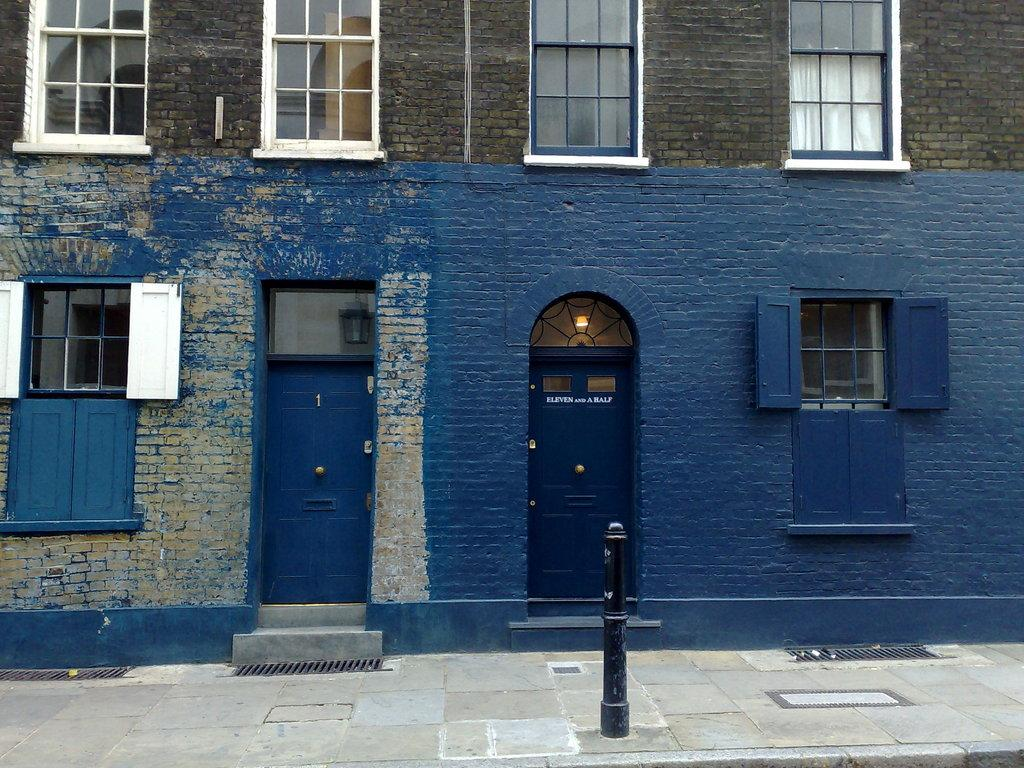What type of structure is visible in the image? There is a building in the image. What features can be seen on the building? The building has windows and doors. What is located in front of the building? There is a black color pole in front of the building. What type of holiday decoration can be seen hanging from the windows of the building? There is no holiday decoration visible in the image; the building only has windows and doors. 